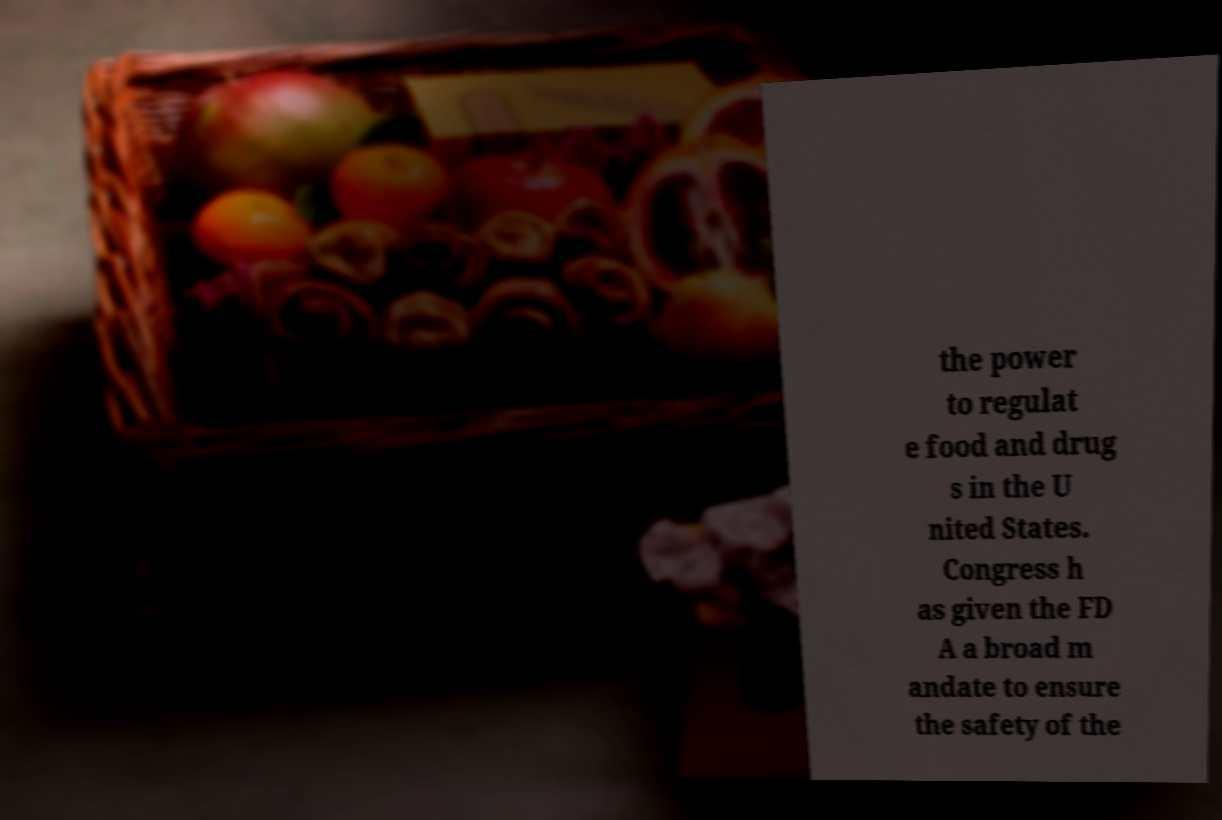Can you read and provide the text displayed in the image?This photo seems to have some interesting text. Can you extract and type it out for me? the power to regulat e food and drug s in the U nited States. Congress h as given the FD A a broad m andate to ensure the safety of the 